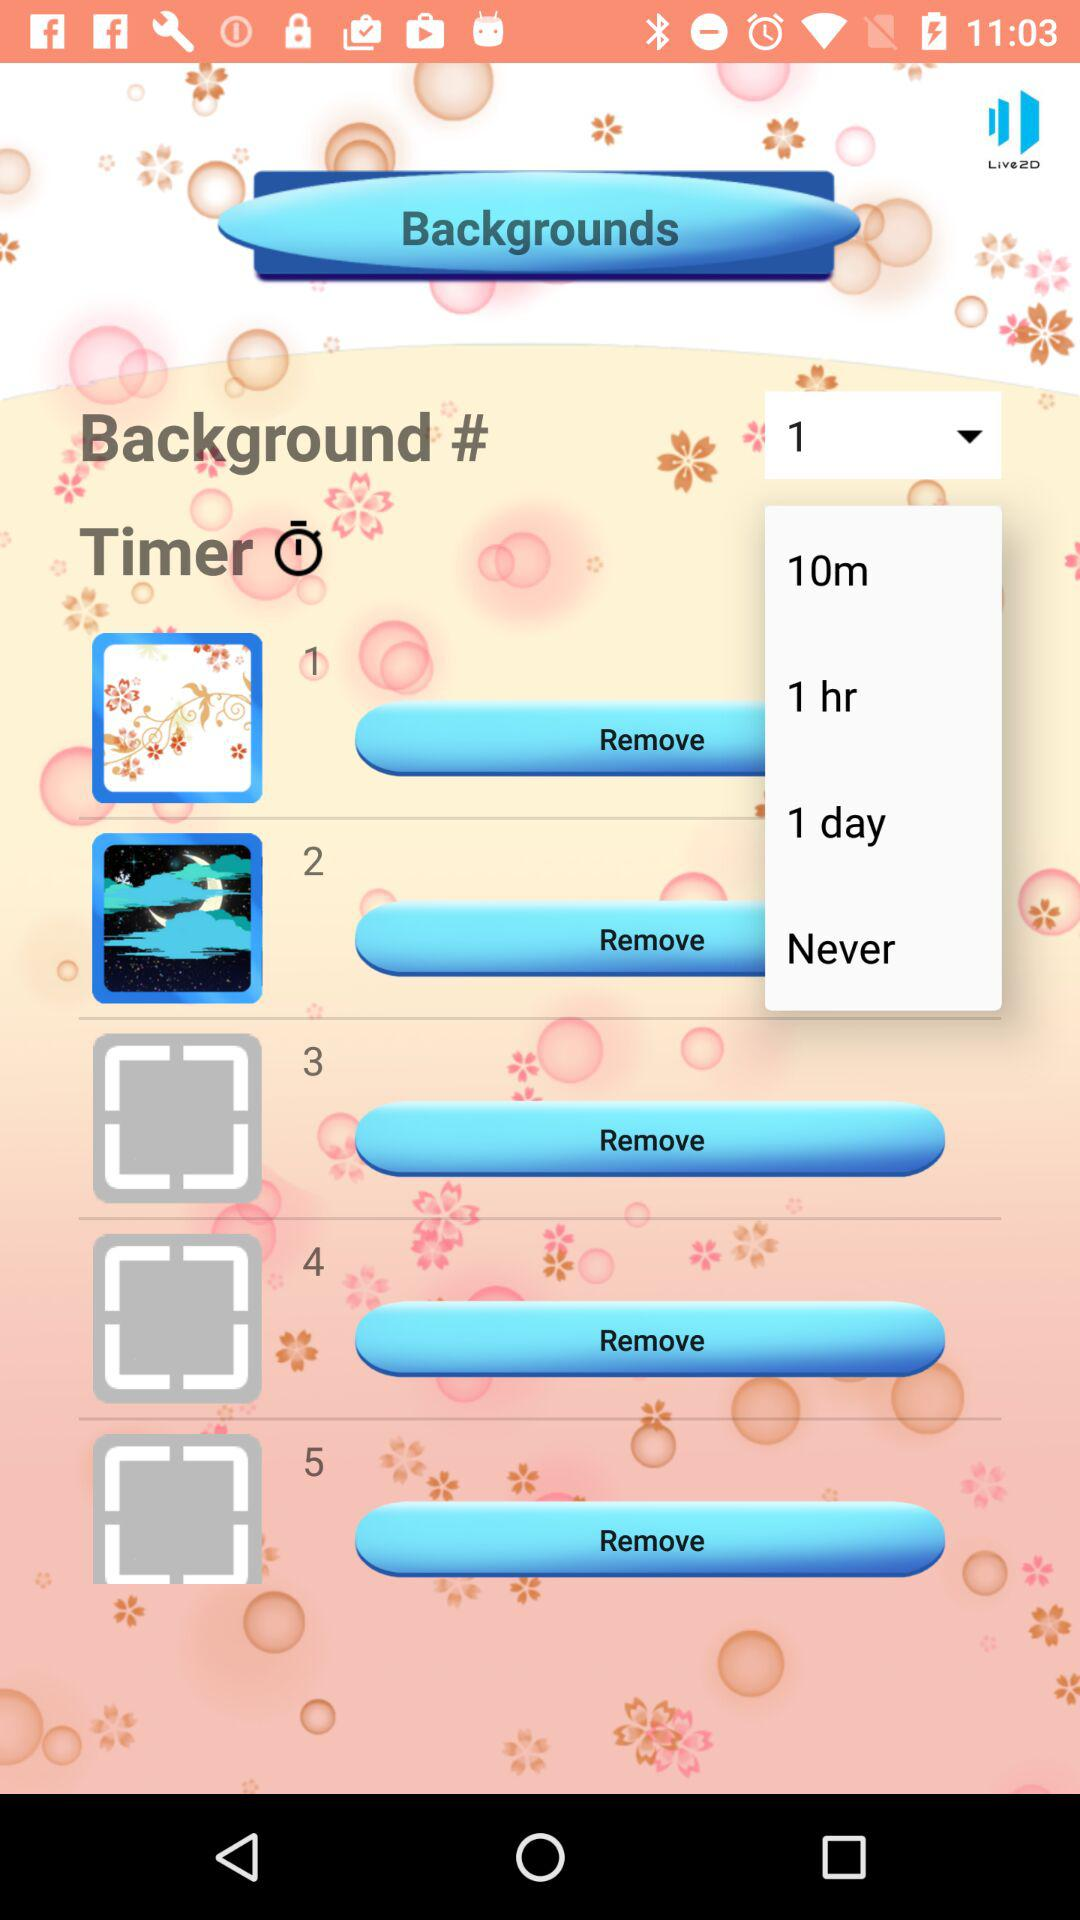How many items have a timer of 1 hour or more?
Answer the question using a single word or phrase. 2 